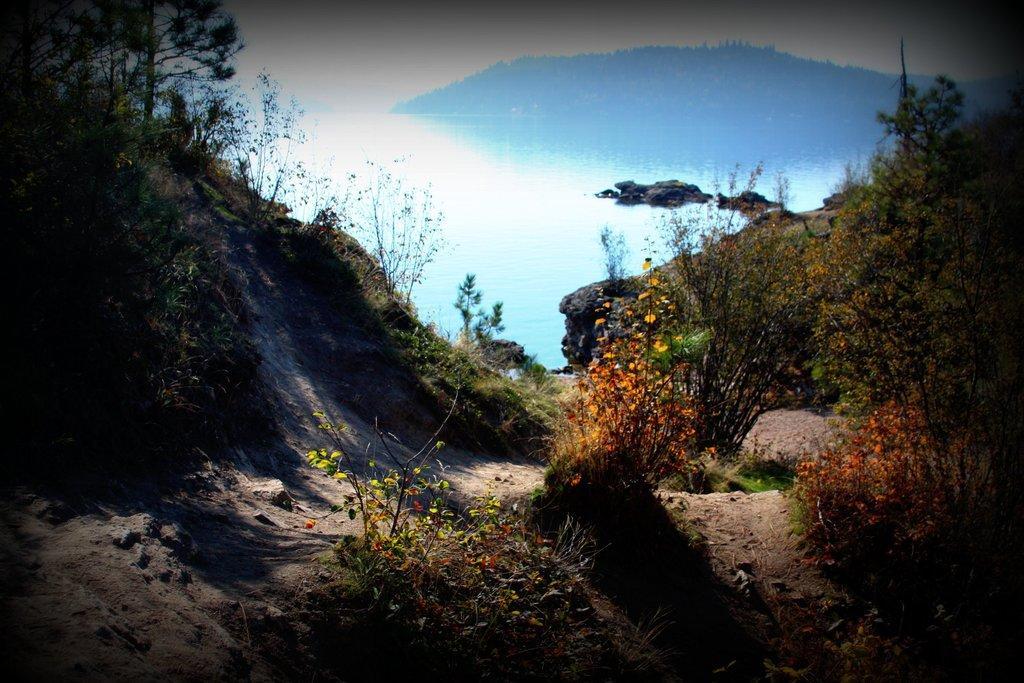How would you summarize this image in a sentence or two? In this image we can see the flowers on the right side. Here we can see the trees on the left side and the right side as well. In the background, we can see the ocean. 